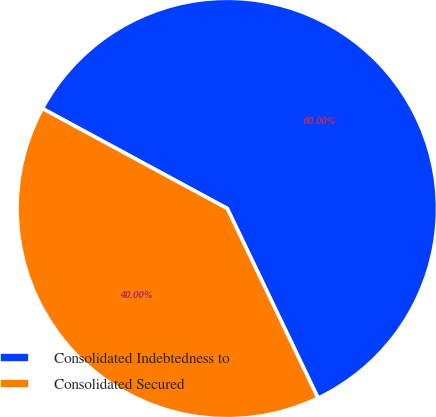Convert chart to OTSL. <chart><loc_0><loc_0><loc_500><loc_500><pie_chart><fcel>Consolidated Indebtedness to<fcel>Consolidated Secured<nl><fcel>60.0%<fcel>40.0%<nl></chart> 